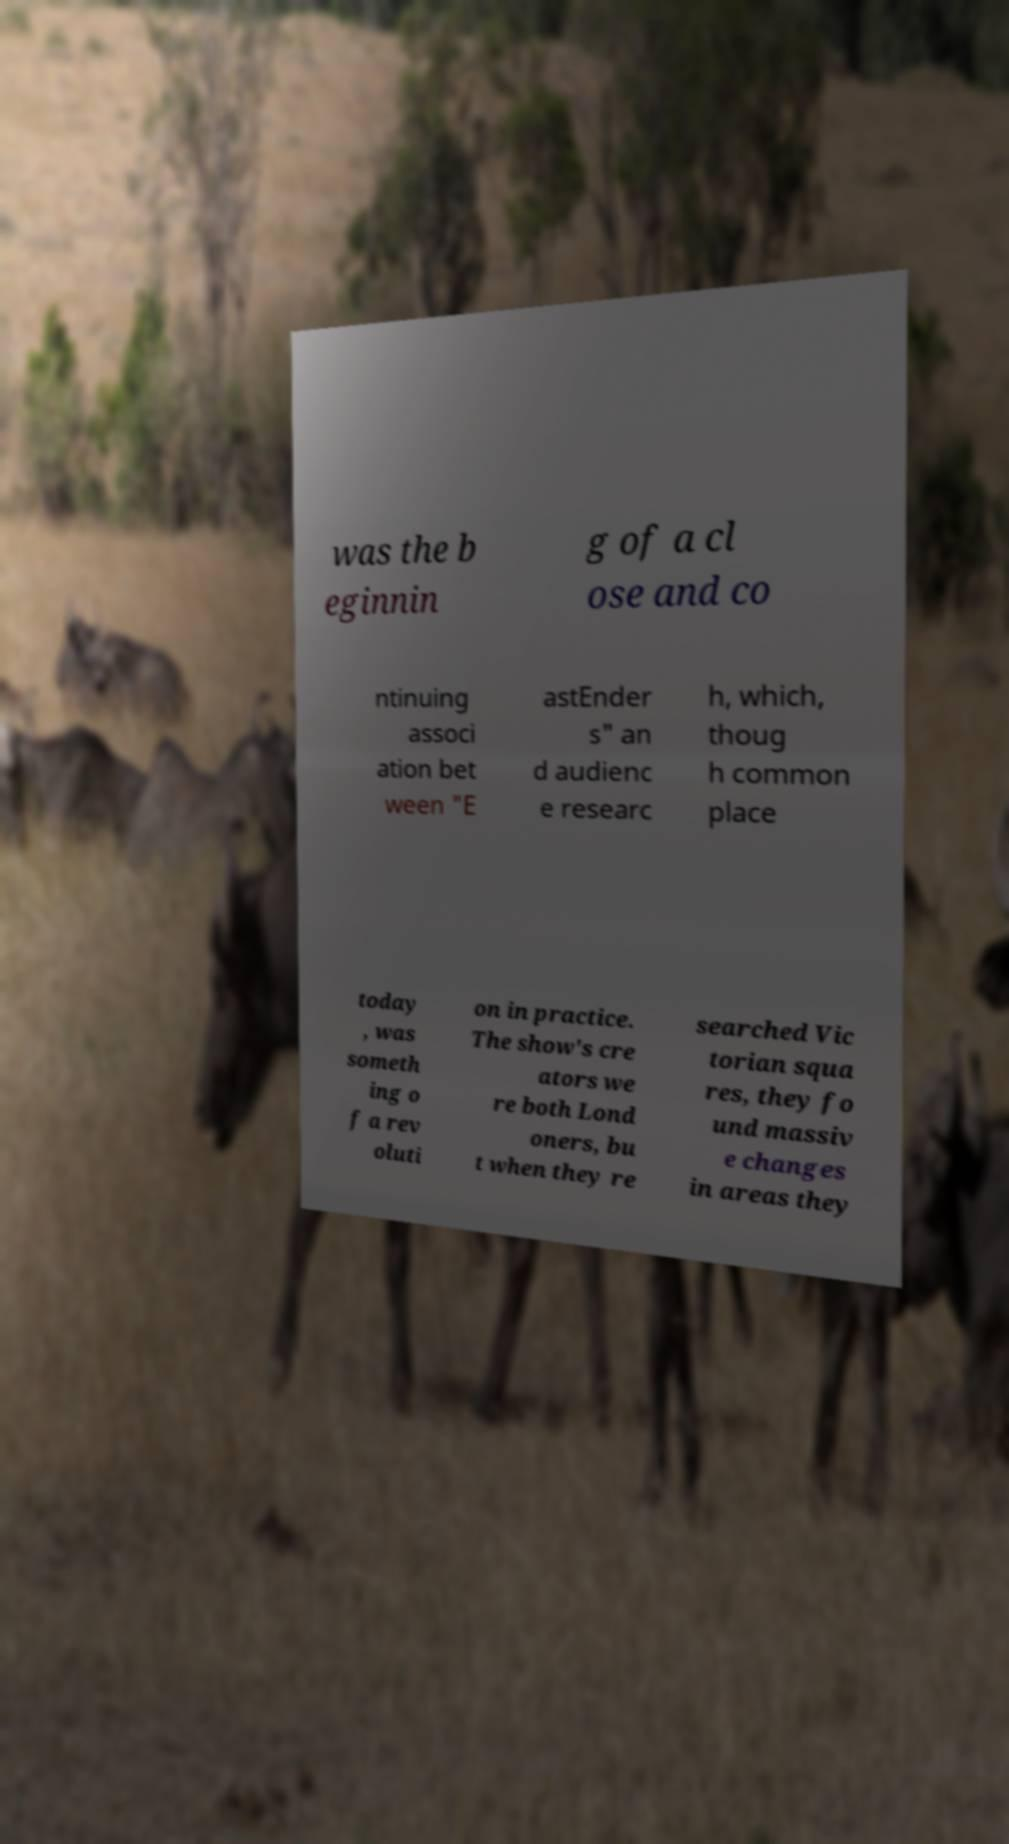What messages or text are displayed in this image? I need them in a readable, typed format. was the b eginnin g of a cl ose and co ntinuing associ ation bet ween "E astEnder s" an d audienc e researc h, which, thoug h common place today , was someth ing o f a rev oluti on in practice. The show's cre ators we re both Lond oners, bu t when they re searched Vic torian squa res, they fo und massiv e changes in areas they 